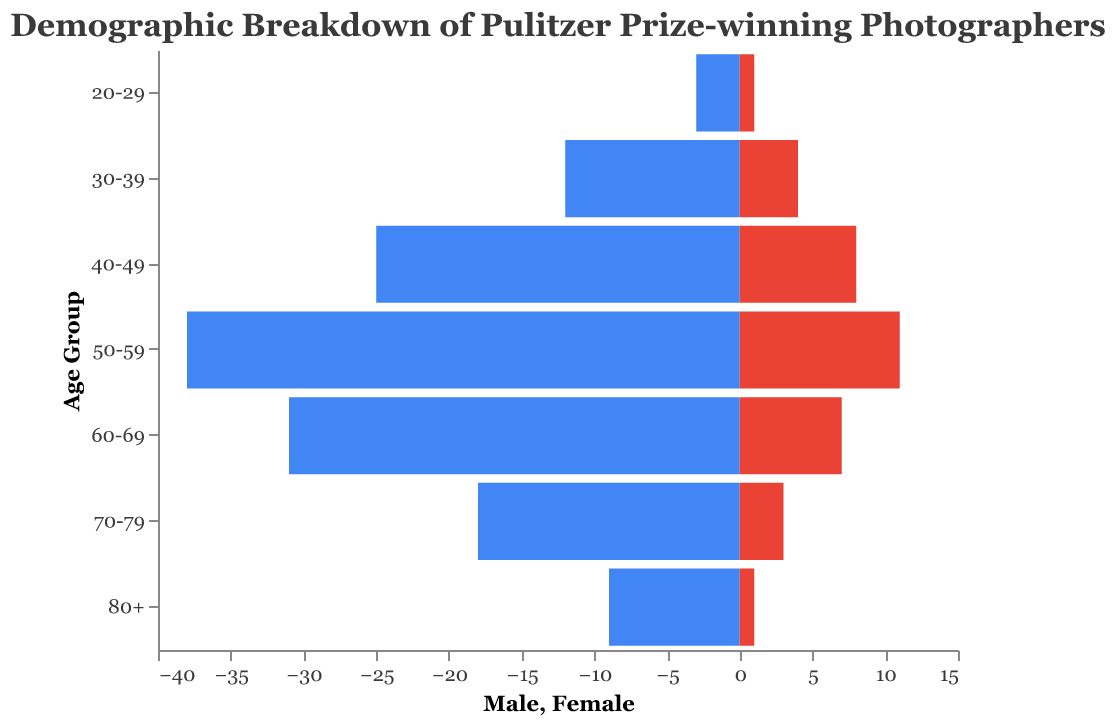How many age groups are represented in the figure? The figure shows the age distribution for Pulitzer Prize-winning photographers. Count the distinct categories along the y-axis.
Answer: 7 Which age group has the highest number of male Pulitzer Prize-winning photographers? Look at the blue bars extending to the left for each age group. The group with the longest bar is the one with the highest number of males.
Answer: 50-59 How many Pulitzer Prize-winning female photographers are aged between 30-39? Find the red bar corresponding to the "30-39" age group and read its value.
Answer: 4 What is the total number of Pulitzer Prize-winning photographers aged 60-69? Add the number of males and females in the "60-69" age group: 31 (males) + 7 (females).
Answer: 38 How does the number of male Pulitzer Prize-winning photographers aged 70-79 compare to those aged 20-29? Compare the lengths of the blue bars for the "70-79" and "20-29" age groups. Specifically, compare the values 18 (70-79) and 3 (20-29).
Answer: More males aged 70-79 Which gender has a larger percentage of photographers aged 80 and above? Calculate the proportions: There are 9 males and 1 female in the 80+ category. The total is 10, so males are 9/10 = 90%, females are 1/10 = 10%.
Answer: Male What is the difference in the number of female Pulitzer Prize-winning photographers between the age groups 40-49 and 50-59? Subtract the number of females in the "40-49" group from those in the "50-59" group: 11 - 8.
Answer: 3 In which age group is the gender disparity most pronounced among Pulitzer Prize-winning photographers? Look for the age group with the largest difference between the lengths of the blue and red bars. The largest difference appears in the "50-59" age group (38 males - 11 females).
Answer: 50-59 What is the average number of female Pulitzer Prize-winning photographers across all age groups? Add the number of females in all age groups and divide by the number of age groups: (1+4+8+11+7+3+1)/7.
Answer: 5 Which age group has the smallest proportion of female Pulitzer Prize-winning photographers relative to males? Compare the ratio of females to males for each age group. For the "80+" age group, there is 1 female to 9 males, which is the smallest proportion.
Answer: 80+ 